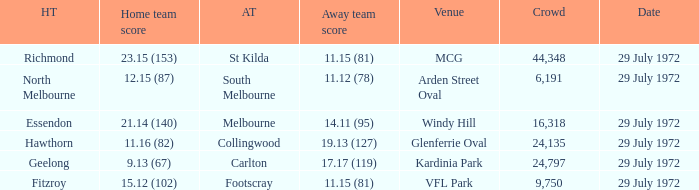What was the greatest gathering size at arden street oval? 6191.0. 